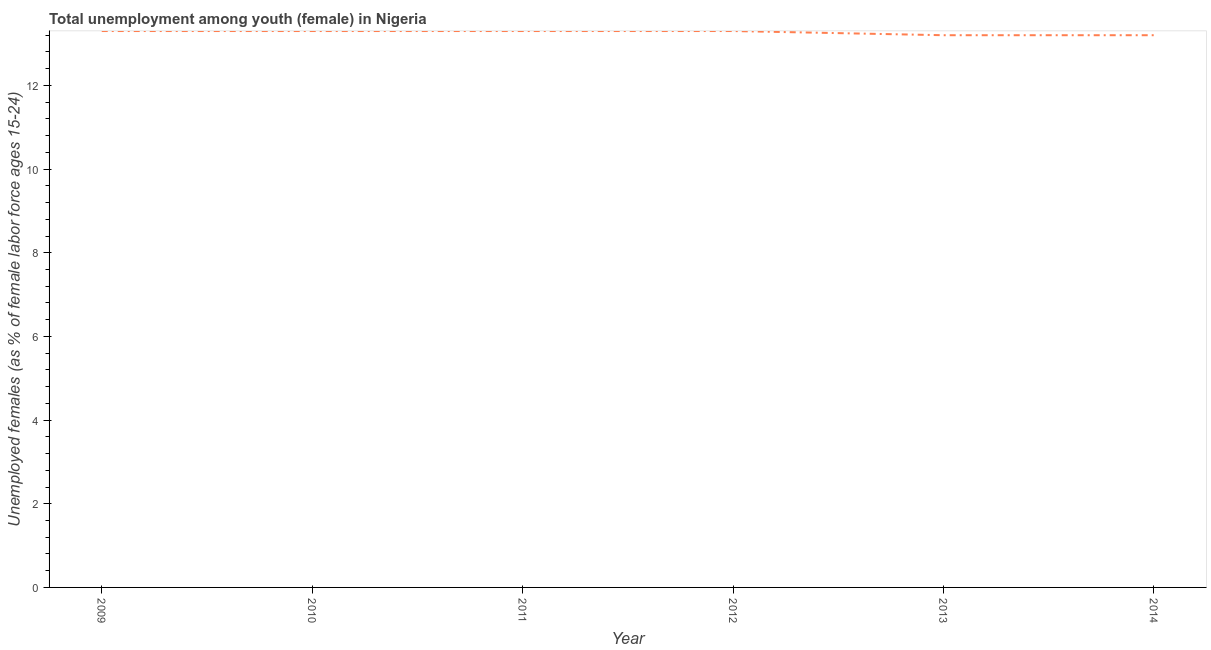What is the unemployed female youth population in 2011?
Your response must be concise. 13.3. Across all years, what is the maximum unemployed female youth population?
Your response must be concise. 13.3. Across all years, what is the minimum unemployed female youth population?
Your answer should be compact. 13.2. In which year was the unemployed female youth population maximum?
Offer a terse response. 2009. What is the sum of the unemployed female youth population?
Ensure brevity in your answer.  79.6. What is the average unemployed female youth population per year?
Offer a very short reply. 13.27. What is the median unemployed female youth population?
Provide a short and direct response. 13.3. Do a majority of the years between 2009 and 2011 (inclusive) have unemployed female youth population greater than 7.2 %?
Give a very brief answer. Yes. Is the unemployed female youth population in 2010 less than that in 2012?
Give a very brief answer. No. Is the sum of the unemployed female youth population in 2009 and 2010 greater than the maximum unemployed female youth population across all years?
Your response must be concise. Yes. What is the difference between the highest and the lowest unemployed female youth population?
Your answer should be very brief. 0.1. In how many years, is the unemployed female youth population greater than the average unemployed female youth population taken over all years?
Provide a short and direct response. 4. Does the unemployed female youth population monotonically increase over the years?
Make the answer very short. No. What is the difference between two consecutive major ticks on the Y-axis?
Your response must be concise. 2. Are the values on the major ticks of Y-axis written in scientific E-notation?
Provide a short and direct response. No. Does the graph contain grids?
Make the answer very short. No. What is the title of the graph?
Your response must be concise. Total unemployment among youth (female) in Nigeria. What is the label or title of the X-axis?
Keep it short and to the point. Year. What is the label or title of the Y-axis?
Your answer should be very brief. Unemployed females (as % of female labor force ages 15-24). What is the Unemployed females (as % of female labor force ages 15-24) of 2009?
Provide a succinct answer. 13.3. What is the Unemployed females (as % of female labor force ages 15-24) in 2010?
Provide a short and direct response. 13.3. What is the Unemployed females (as % of female labor force ages 15-24) in 2011?
Your response must be concise. 13.3. What is the Unemployed females (as % of female labor force ages 15-24) of 2012?
Your answer should be compact. 13.3. What is the Unemployed females (as % of female labor force ages 15-24) in 2013?
Make the answer very short. 13.2. What is the Unemployed females (as % of female labor force ages 15-24) in 2014?
Your response must be concise. 13.2. What is the difference between the Unemployed females (as % of female labor force ages 15-24) in 2009 and 2010?
Offer a very short reply. 0. What is the difference between the Unemployed females (as % of female labor force ages 15-24) in 2009 and 2011?
Your response must be concise. 0. What is the difference between the Unemployed females (as % of female labor force ages 15-24) in 2009 and 2013?
Make the answer very short. 0.1. What is the difference between the Unemployed females (as % of female labor force ages 15-24) in 2010 and 2013?
Offer a terse response. 0.1. What is the difference between the Unemployed females (as % of female labor force ages 15-24) in 2012 and 2014?
Provide a succinct answer. 0.1. What is the difference between the Unemployed females (as % of female labor force ages 15-24) in 2013 and 2014?
Make the answer very short. 0. What is the ratio of the Unemployed females (as % of female labor force ages 15-24) in 2009 to that in 2012?
Make the answer very short. 1. What is the ratio of the Unemployed females (as % of female labor force ages 15-24) in 2009 to that in 2014?
Ensure brevity in your answer.  1.01. What is the ratio of the Unemployed females (as % of female labor force ages 15-24) in 2010 to that in 2012?
Provide a succinct answer. 1. What is the ratio of the Unemployed females (as % of female labor force ages 15-24) in 2010 to that in 2013?
Your answer should be compact. 1.01. What is the ratio of the Unemployed females (as % of female labor force ages 15-24) in 2010 to that in 2014?
Your answer should be very brief. 1.01. What is the ratio of the Unemployed females (as % of female labor force ages 15-24) in 2011 to that in 2014?
Give a very brief answer. 1.01. What is the ratio of the Unemployed females (as % of female labor force ages 15-24) in 2012 to that in 2013?
Offer a very short reply. 1.01. 